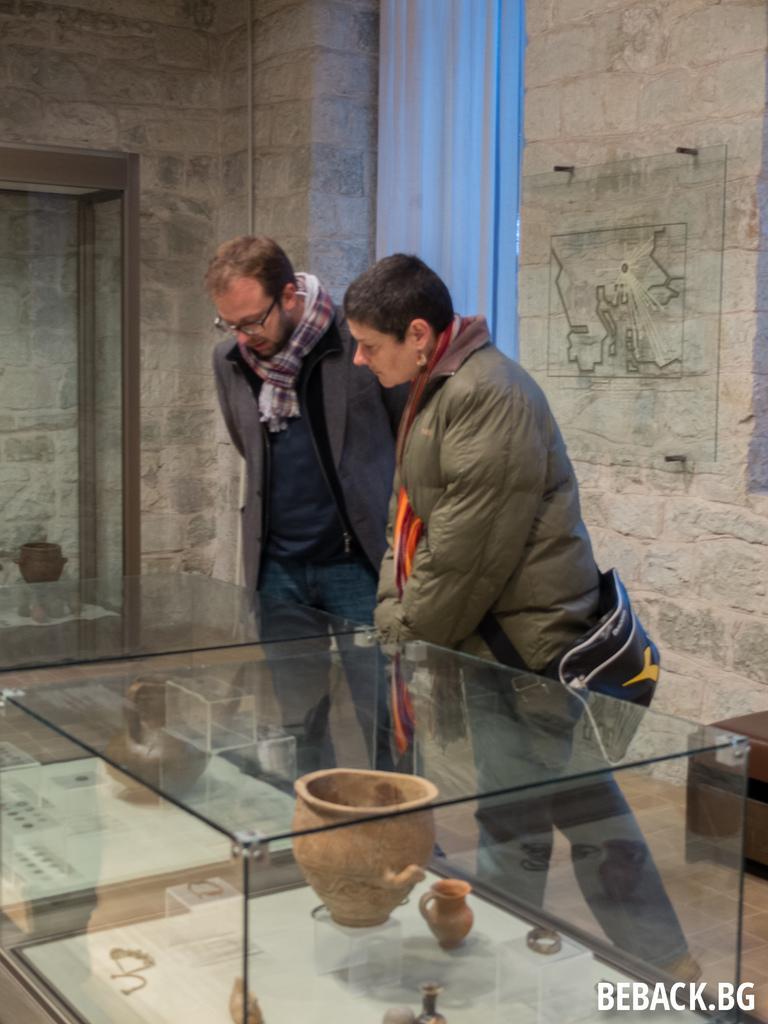Please provide a concise description of this image. In this image, we can see two people are standing near the glass boxes. In the glass boxes, we can see few objects. Background there is a wall, door, curtain and glass. Right side of the image, there is a table on the floor. Here we can see a watermark in the image. 